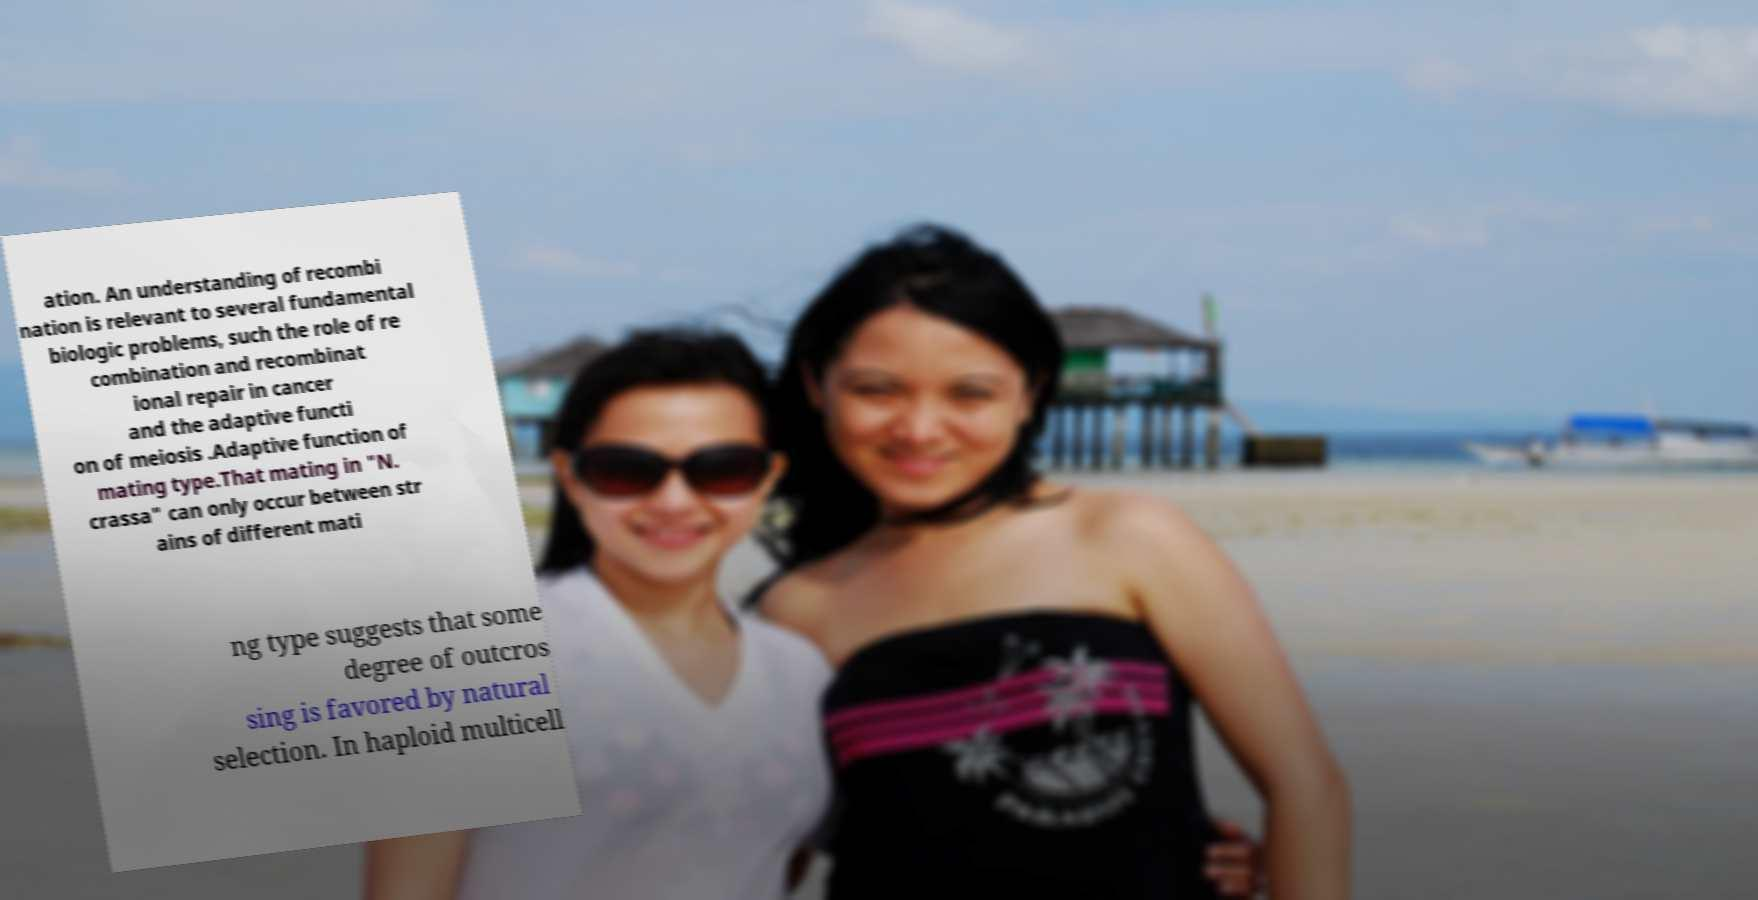I need the written content from this picture converted into text. Can you do that? ation. An understanding of recombi nation is relevant to several fundamental biologic problems, such the role of re combination and recombinat ional repair in cancer and the adaptive functi on of meiosis .Adaptive function of mating type.That mating in "N. crassa" can only occur between str ains of different mati ng type suggests that some degree of outcros sing is favored by natural selection. In haploid multicell 